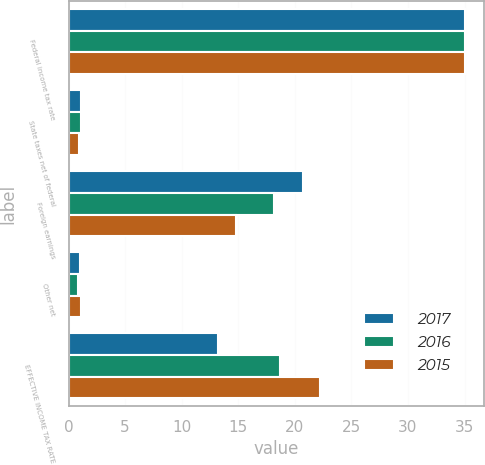Convert chart to OTSL. <chart><loc_0><loc_0><loc_500><loc_500><stacked_bar_chart><ecel><fcel>Federal income tax rate<fcel>State taxes net of federal<fcel>Foreign earnings<fcel>Other net<fcel>EFFECTIVE INCOME TAX RATE<nl><fcel>2017<fcel>35<fcel>1.1<fcel>20.7<fcel>1<fcel>13.2<nl><fcel>2016<fcel>35<fcel>1.1<fcel>18.2<fcel>0.8<fcel>18.7<nl><fcel>2015<fcel>35<fcel>0.9<fcel>14.8<fcel>1.1<fcel>22.2<nl></chart> 